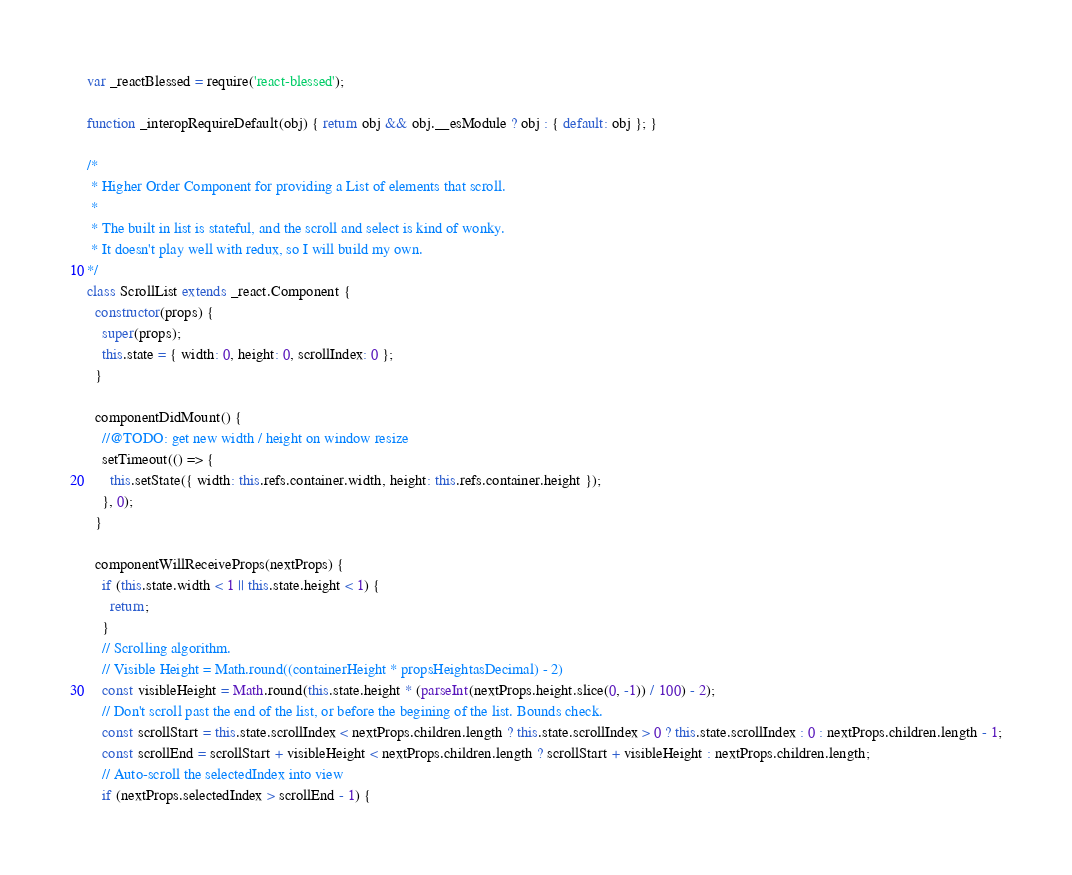<code> <loc_0><loc_0><loc_500><loc_500><_JavaScript_>
var _reactBlessed = require('react-blessed');

function _interopRequireDefault(obj) { return obj && obj.__esModule ? obj : { default: obj }; }

/*
 * Higher Order Component for providing a List of elements that scroll.
 *
 * The built in list is stateful, and the scroll and select is kind of wonky.
 * It doesn't play well with redux, so I will build my own.
*/
class ScrollList extends _react.Component {
  constructor(props) {
    super(props);
    this.state = { width: 0, height: 0, scrollIndex: 0 };
  }

  componentDidMount() {
    //@TODO: get new width / height on window resize
    setTimeout(() => {
      this.setState({ width: this.refs.container.width, height: this.refs.container.height });
    }, 0);
  }

  componentWillReceiveProps(nextProps) {
    if (this.state.width < 1 || this.state.height < 1) {
      return;
    }
    // Scrolling algorithm.
    // Visible Height = Math.round((containerHeight * propsHeightasDecimal) - 2)
    const visibleHeight = Math.round(this.state.height * (parseInt(nextProps.height.slice(0, -1)) / 100) - 2);
    // Don't scroll past the end of the list, or before the begining of the list. Bounds check.
    const scrollStart = this.state.scrollIndex < nextProps.children.length ? this.state.scrollIndex > 0 ? this.state.scrollIndex : 0 : nextProps.children.length - 1;
    const scrollEnd = scrollStart + visibleHeight < nextProps.children.length ? scrollStart + visibleHeight : nextProps.children.length;
    // Auto-scroll the selectedIndex into view
    if (nextProps.selectedIndex > scrollEnd - 1) {</code> 